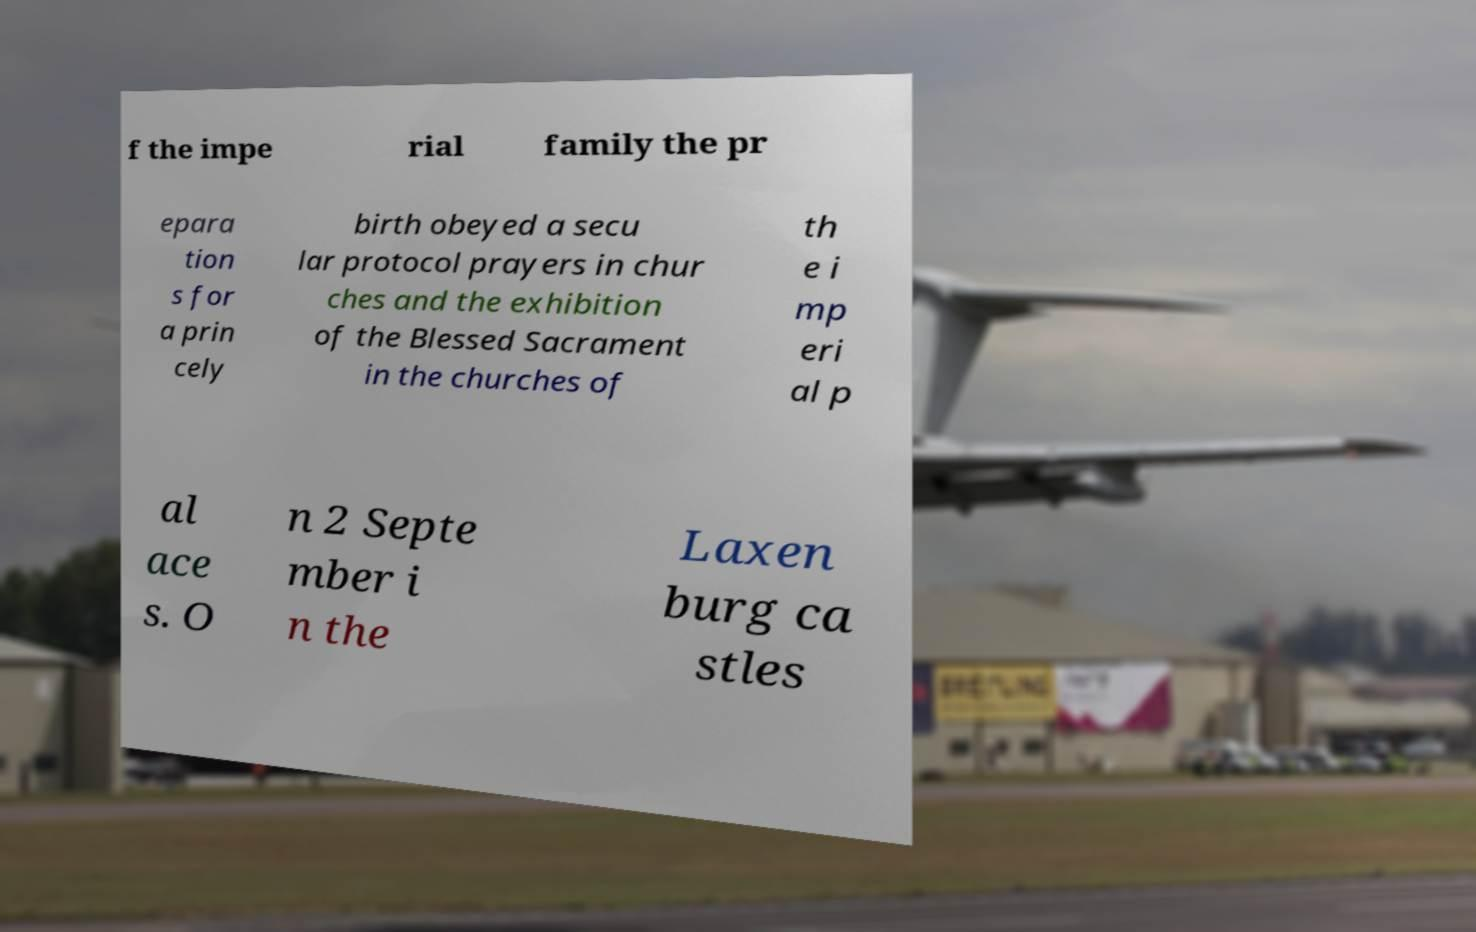What messages or text are displayed in this image? I need them in a readable, typed format. f the impe rial family the pr epara tion s for a prin cely birth obeyed a secu lar protocol prayers in chur ches and the exhibition of the Blessed Sacrament in the churches of th e i mp eri al p al ace s. O n 2 Septe mber i n the Laxen burg ca stles 